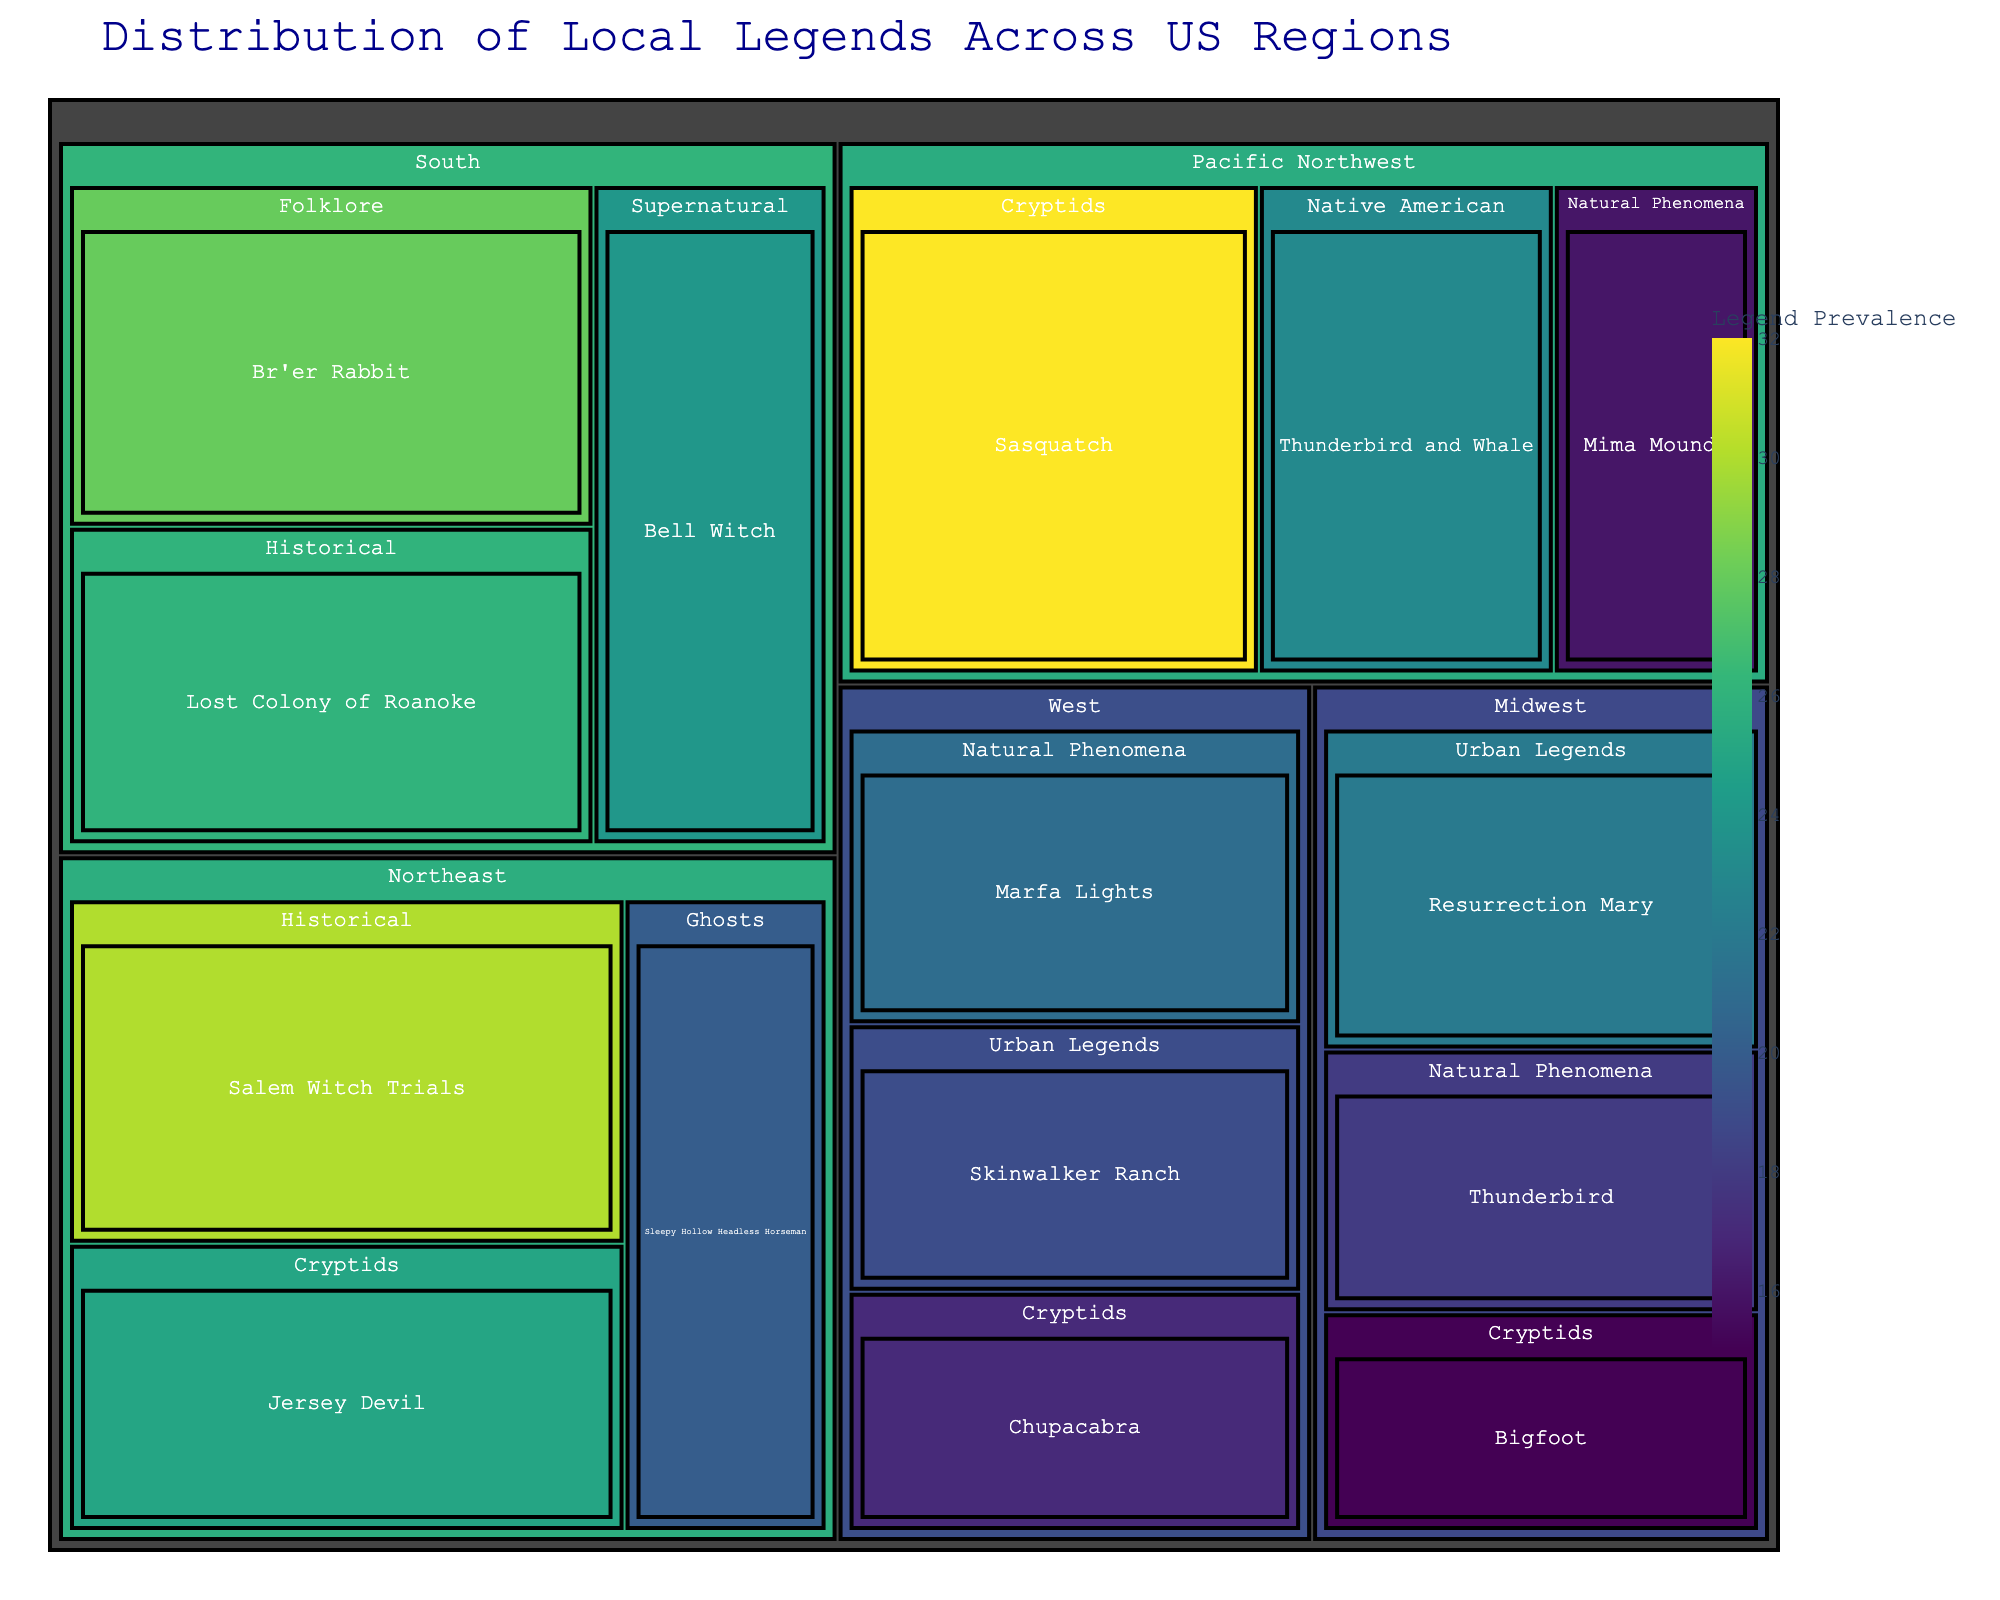What is the total number of legends in the Northeast region? The Northeast region's legends are 'Jersey Devil' (25), 'Sleepy Hollow Headless Horseman' (20), and 'Salem Witch Trials' (30). Adding these values gives: 25 + 20 + 30 = 75
Answer: 75 Which region has the highest value for a single legend? The Pacific Northwest has 'Sasquatch' with a value of 32, which is higher than all other single legend values listed.
Answer: Pacific Northwest How does the value of the 'Bell Witch' legend compare to the 'Marfa Lights' legend? The 'Bell Witch' has a value of 24, while the 'Marfa Lights' legend has a value of 21. Therefore, 'Bell Witch' has a higher value.
Answer: Bell Witch > Marfa Lights What is the value difference between the 'Thunderbird and Whale' legend in the Pacific Northwest and the 'Thunderbird' legend in the Midwest? The 'Thunderbird and Whale' has a value of 23, and the 'Thunderbird' in the Midwest has a value of 18. The difference is: 23 - 18 = 5
Answer: 5 Which theme has more legends in the West region - Urban Legends or Cryptids? The West region's Urban Legends have 'Skinwalker Ranch' (19), and Cryptids have 'Chupacabra' (17). Urban Legends in the West have a higher value.
Answer: Urban Legends How many themes are represented in the Midwest region? The Midwest has the following themes represented: Cryptids, Natural Phenomena, and Urban Legends. This totals 3 themes.
Answer: 3 Which legend has the lowest value, and in which region is it located? The legend with the lowest value is 'Thunderbird' in the Midwest which has a value of 18.
Answer: Midwest Compare the total values of Historical legends in the Northeast and South regions. The Northeast Historical legend is 'Salem Witch Trials' valued at 30. The South Historical legend is 'Lost Colony of Roanoke' valued at 26. The Northeast's total is 30, and the South's total is 26.
Answer: Northeast > South What is the combined value of all supernatural-themed legends? The only Supernatural legend listed is 'Bell Witch' with a value of 24. Hence, 24 is the combined value.
Answer: 24 